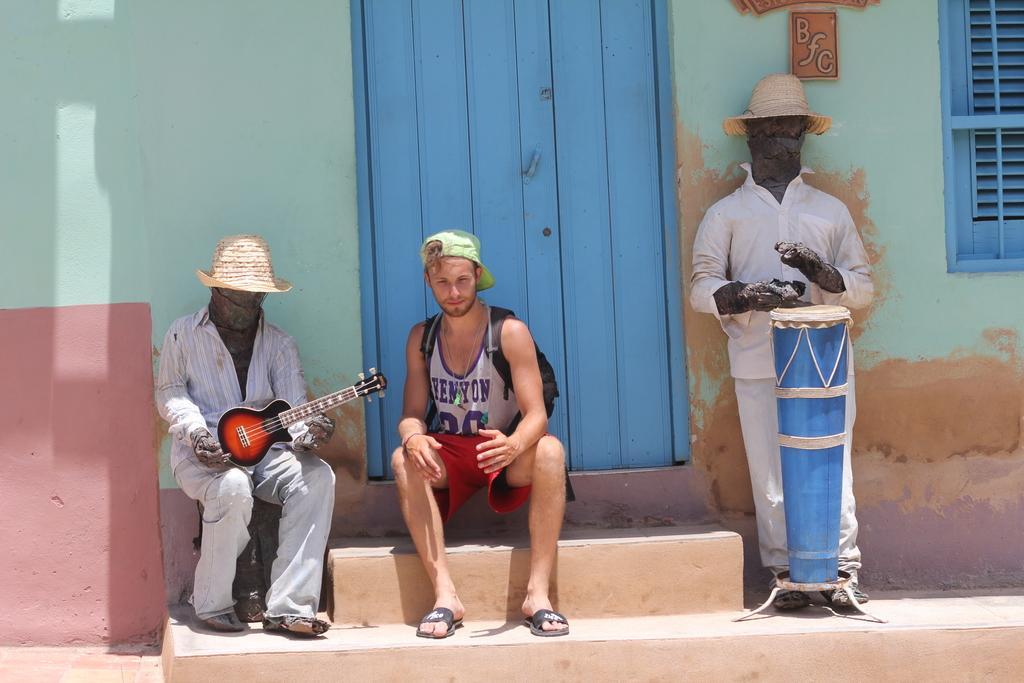Please provide a concise description of this image. In this picture there are two statues wearing hats. One statue is having a guitar in its hand and the other statue is having a drum in front of it and the person is sitting on the steps in between the. In the background, there is a door and a wall here. 